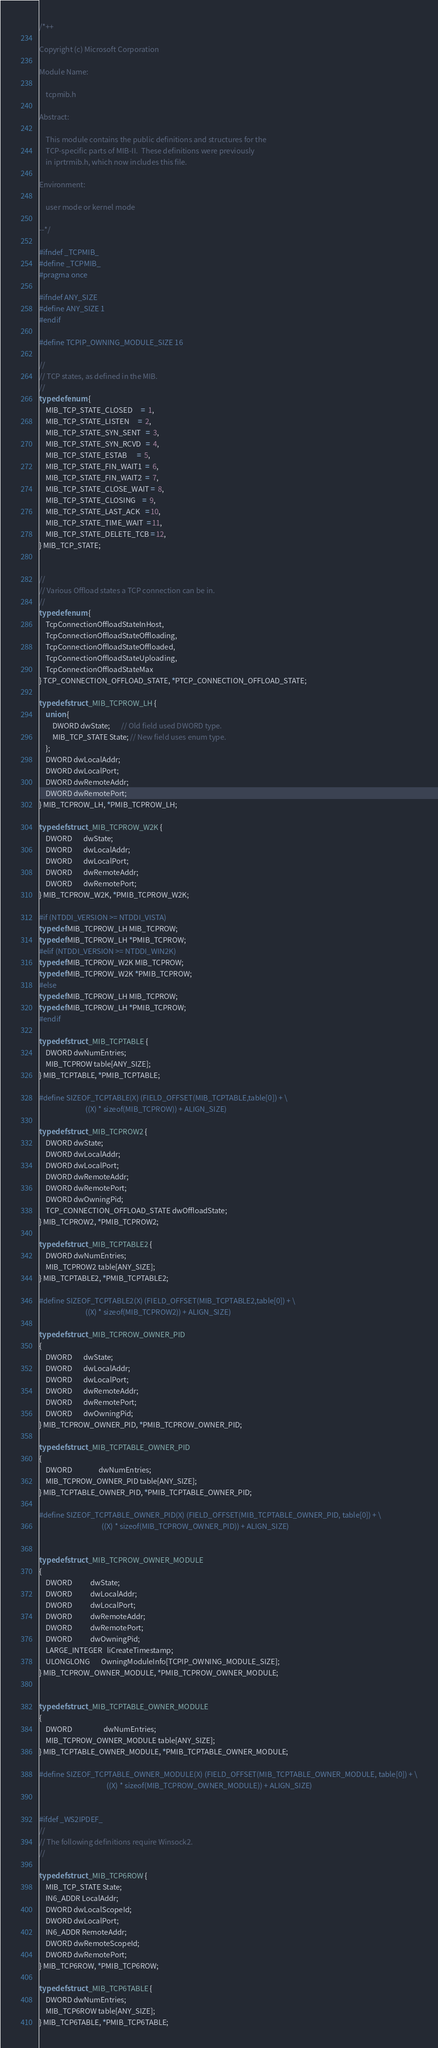<code> <loc_0><loc_0><loc_500><loc_500><_C_>/*++

Copyright (c) Microsoft Corporation

Module Name:

    tcpmib.h

Abstract:

    This module contains the public definitions and structures for the
    TCP-specific parts of MIB-II.  These definitions were previously
    in iprtrmib.h, which now includes this file.

Environment:

    user mode or kernel mode

--*/

#ifndef _TCPMIB_
#define _TCPMIB_
#pragma once

#ifndef ANY_SIZE
#define ANY_SIZE 1
#endif

#define TCPIP_OWNING_MODULE_SIZE 16

//
// TCP states, as defined in the MIB.
//
typedef enum {
    MIB_TCP_STATE_CLOSED     =  1,
    MIB_TCP_STATE_LISTEN     =  2,
    MIB_TCP_STATE_SYN_SENT   =  3,
    MIB_TCP_STATE_SYN_RCVD   =  4,
    MIB_TCP_STATE_ESTAB      =  5,
    MIB_TCP_STATE_FIN_WAIT1  =  6,
    MIB_TCP_STATE_FIN_WAIT2  =  7,
    MIB_TCP_STATE_CLOSE_WAIT =  8,
    MIB_TCP_STATE_CLOSING    =  9,
    MIB_TCP_STATE_LAST_ACK   = 10,
    MIB_TCP_STATE_TIME_WAIT  = 11,
    MIB_TCP_STATE_DELETE_TCB = 12,
} MIB_TCP_STATE;


//
// Various Offload states a TCP connection can be in.
//
typedef enum {
    TcpConnectionOffloadStateInHost,
    TcpConnectionOffloadStateOffloading,
    TcpConnectionOffloadStateOffloaded,
    TcpConnectionOffloadStateUploading,
    TcpConnectionOffloadStateMax
} TCP_CONNECTION_OFFLOAD_STATE, *PTCP_CONNECTION_OFFLOAD_STATE;

typedef struct _MIB_TCPROW_LH {
    union {
        DWORD dwState;       // Old field used DWORD type.
        MIB_TCP_STATE State; // New field uses enum type.
    };
    DWORD dwLocalAddr;
    DWORD dwLocalPort;
    DWORD dwRemoteAddr;
    DWORD dwRemotePort;
} MIB_TCPROW_LH, *PMIB_TCPROW_LH;

typedef struct _MIB_TCPROW_W2K {
    DWORD       dwState;
    DWORD       dwLocalAddr;
    DWORD       dwLocalPort;
    DWORD       dwRemoteAddr;
    DWORD       dwRemotePort;
} MIB_TCPROW_W2K, *PMIB_TCPROW_W2K;

#if (NTDDI_VERSION >= NTDDI_VISTA)
typedef MIB_TCPROW_LH MIB_TCPROW;
typedef MIB_TCPROW_LH *PMIB_TCPROW;
#elif (NTDDI_VERSION >= NTDDI_WIN2K)
typedef MIB_TCPROW_W2K MIB_TCPROW;
typedef MIB_TCPROW_W2K *PMIB_TCPROW;
#else
typedef MIB_TCPROW_LH MIB_TCPROW;
typedef MIB_TCPROW_LH *PMIB_TCPROW;
#endif

typedef struct _MIB_TCPTABLE {
    DWORD dwNumEntries;
    MIB_TCPROW table[ANY_SIZE];
} MIB_TCPTABLE, *PMIB_TCPTABLE;

#define SIZEOF_TCPTABLE(X) (FIELD_OFFSET(MIB_TCPTABLE,table[0]) + \
                            ((X) * sizeof(MIB_TCPROW)) + ALIGN_SIZE)

typedef struct _MIB_TCPROW2 {
    DWORD dwState;
    DWORD dwLocalAddr;
    DWORD dwLocalPort;
    DWORD dwRemoteAddr;
    DWORD dwRemotePort;
    DWORD dwOwningPid;
    TCP_CONNECTION_OFFLOAD_STATE dwOffloadState;
} MIB_TCPROW2, *PMIB_TCPROW2;

typedef struct _MIB_TCPTABLE2 {
    DWORD dwNumEntries;
    MIB_TCPROW2 table[ANY_SIZE];
} MIB_TCPTABLE2, *PMIB_TCPTABLE2;

#define SIZEOF_TCPTABLE2(X) (FIELD_OFFSET(MIB_TCPTABLE2,table[0]) + \
                            ((X) * sizeof(MIB_TCPROW2)) + ALIGN_SIZE)

typedef struct _MIB_TCPROW_OWNER_PID
{
    DWORD       dwState;
    DWORD       dwLocalAddr;
    DWORD       dwLocalPort;
    DWORD       dwRemoteAddr;
    DWORD       dwRemotePort;
    DWORD       dwOwningPid;
} MIB_TCPROW_OWNER_PID, *PMIB_TCPROW_OWNER_PID;

typedef struct _MIB_TCPTABLE_OWNER_PID
{
    DWORD                dwNumEntries;
    MIB_TCPROW_OWNER_PID table[ANY_SIZE];
} MIB_TCPTABLE_OWNER_PID, *PMIB_TCPTABLE_OWNER_PID;

#define SIZEOF_TCPTABLE_OWNER_PID(X) (FIELD_OFFSET(MIB_TCPTABLE_OWNER_PID, table[0]) + \
									  ((X) * sizeof(MIB_TCPROW_OWNER_PID)) + ALIGN_SIZE)


typedef struct _MIB_TCPROW_OWNER_MODULE
{
    DWORD           dwState;
    DWORD           dwLocalAddr;
    DWORD           dwLocalPort;
    DWORD           dwRemoteAddr;
    DWORD           dwRemotePort;
    DWORD           dwOwningPid;
    LARGE_INTEGER   liCreateTimestamp;
    ULONGLONG       OwningModuleInfo[TCPIP_OWNING_MODULE_SIZE];
} MIB_TCPROW_OWNER_MODULE, *PMIB_TCPROW_OWNER_MODULE;


typedef struct _MIB_TCPTABLE_OWNER_MODULE
{
    DWORD                   dwNumEntries;
    MIB_TCPROW_OWNER_MODULE table[ANY_SIZE];
} MIB_TCPTABLE_OWNER_MODULE, *PMIB_TCPTABLE_OWNER_MODULE;

#define SIZEOF_TCPTABLE_OWNER_MODULE(X) (FIELD_OFFSET(MIB_TCPTABLE_OWNER_MODULE, table[0]) + \
										 ((X) * sizeof(MIB_TCPROW_OWNER_MODULE)) + ALIGN_SIZE)

                            
#ifdef _WS2IPDEF_
//
// The following definitions require Winsock2.
//

typedef struct _MIB_TCP6ROW {
    MIB_TCP_STATE State;
    IN6_ADDR LocalAddr;
    DWORD dwLocalScopeId;
    DWORD dwLocalPort;
    IN6_ADDR RemoteAddr;
    DWORD dwRemoteScopeId;
    DWORD dwRemotePort;
} MIB_TCP6ROW, *PMIB_TCP6ROW;

typedef struct _MIB_TCP6TABLE {
    DWORD dwNumEntries;
    MIB_TCP6ROW table[ANY_SIZE];
} MIB_TCP6TABLE, *PMIB_TCP6TABLE;
</code> 